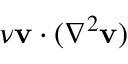<formula> <loc_0><loc_0><loc_500><loc_500>\nu v \cdot ( \nabla ^ { 2 } v )</formula> 